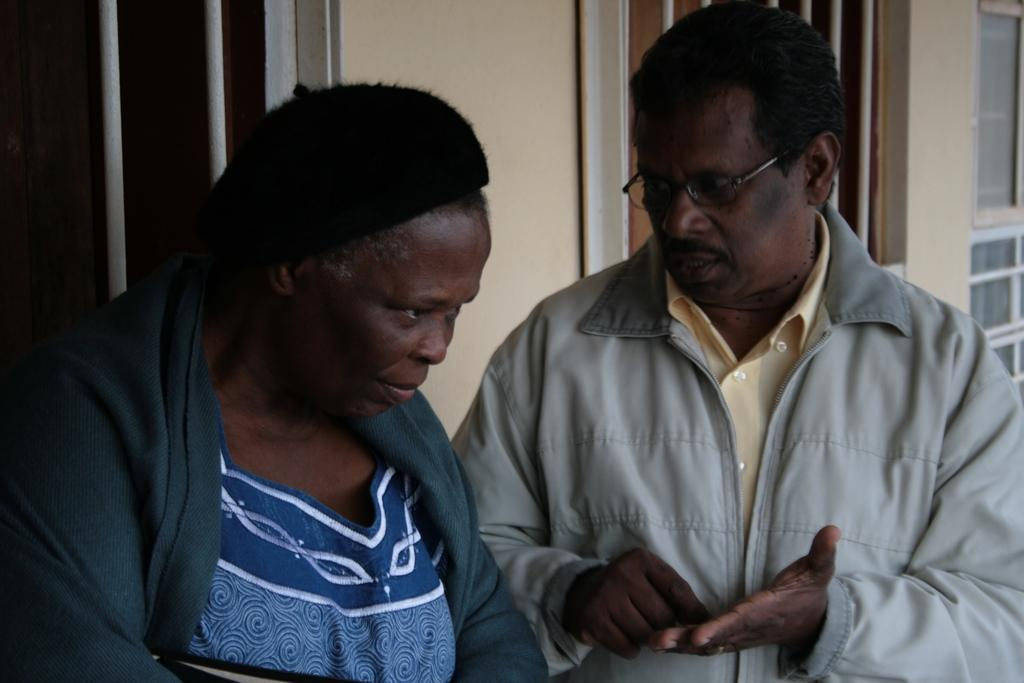How many people are present in the image? There are two people standing in the image. Can you describe the position of the man in the image? The man is standing on the right side of the image. What is the man wearing in the image? The man is wearing a jacket. What can be seen in the background of the image? There is a wall and windows in the background of the image. What songs are being sung by the people in the image? There is no indication in the image that the people are singing songs, so it cannot be determined from the picture. 